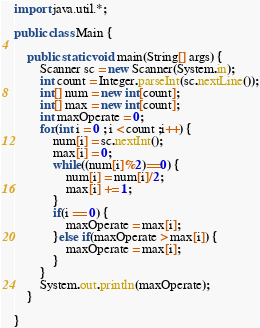<code> <loc_0><loc_0><loc_500><loc_500><_Java_>import java.util.*;

public class Main {

	public static void main(String[] args) {
		Scanner sc = new Scanner(System.in);
		int count = Integer.parseInt(sc.nextLine());
		int[] num = new int[count];
		int[] max = new int[count];
		int maxOperate = 0;
		for(int i = 0 ; i < count ;i++) {
			num[i] = sc.nextInt();
			max[i] = 0;
			while((num[i]%2)==0) {
				num[i] = num[i]/2;
				max[i] += 1;
			}
			if(i == 0) {
				maxOperate = max[i];
			}else if(maxOperate > max[i]) {
				maxOperate = max[i];
			}
		}
		System.out.println(maxOperate);
	}

}
</code> 